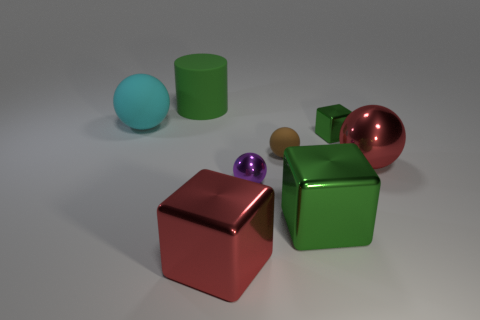How many small shiny balls have the same color as the big metallic sphere?
Provide a short and direct response. 0. How many large things are either red cubes or cyan spheres?
Make the answer very short. 2. Is the tiny brown object to the left of the large red sphere made of the same material as the red block?
Your answer should be compact. No. There is a metallic block behind the large red metallic ball; what is its color?
Offer a terse response. Green. Is there another green cylinder of the same size as the green cylinder?
Offer a terse response. No. What is the material of the brown object that is the same size as the purple ball?
Your response must be concise. Rubber. Do the purple shiny object and the green thing in front of the tiny brown rubber object have the same size?
Keep it short and to the point. No. There is a large ball right of the small green metal cube; what material is it?
Keep it short and to the point. Metal. Is the number of metal cubes on the right side of the red sphere the same as the number of small cubes?
Give a very brief answer. No. Do the red block and the brown rubber ball have the same size?
Provide a succinct answer. No. 